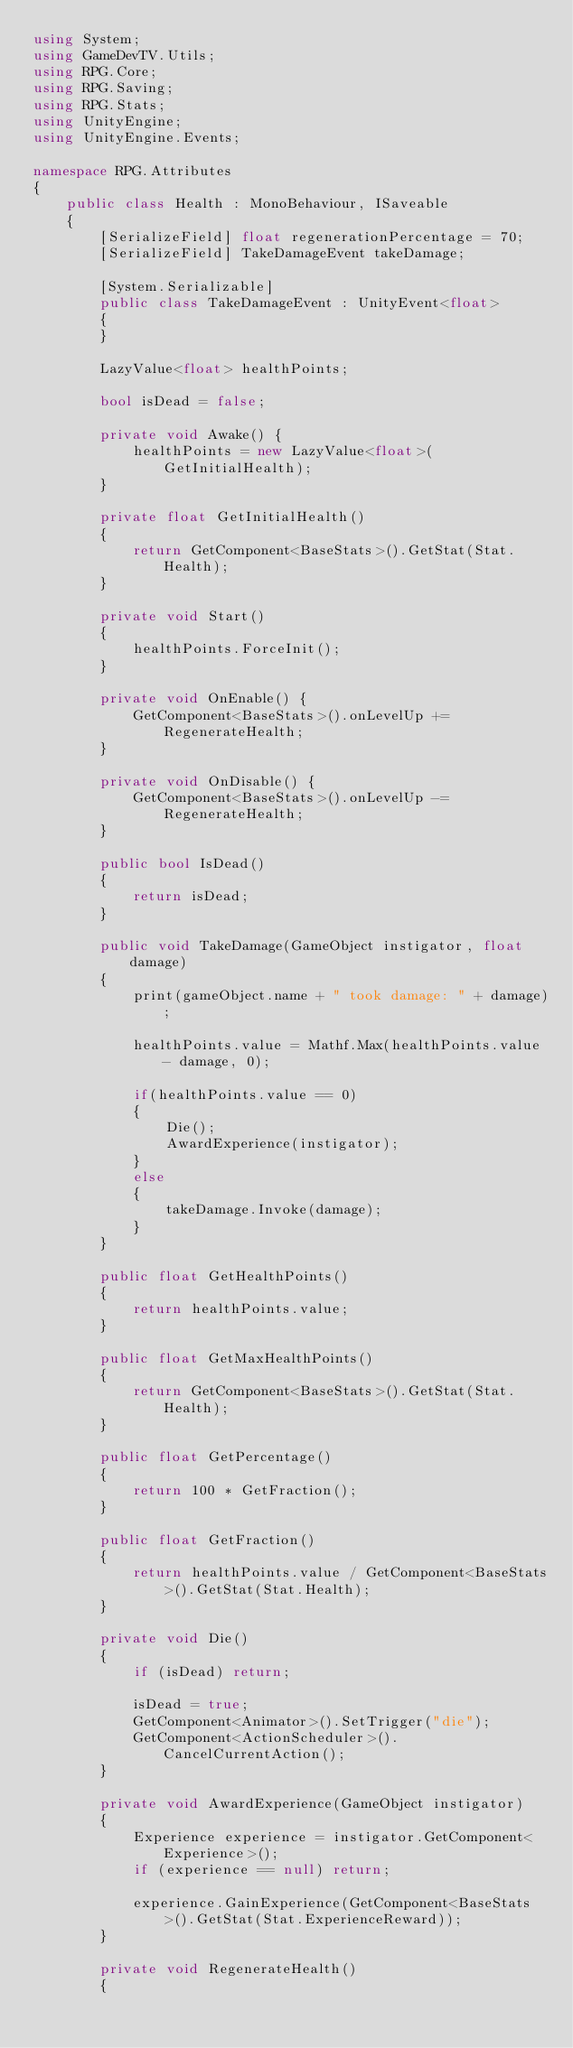Convert code to text. <code><loc_0><loc_0><loc_500><loc_500><_C#_>using System;
using GameDevTV.Utils;
using RPG.Core;
using RPG.Saving;
using RPG.Stats;
using UnityEngine;
using UnityEngine.Events;

namespace RPG.Attributes
{
    public class Health : MonoBehaviour, ISaveable
    {
        [SerializeField] float regenerationPercentage = 70;
        [SerializeField] TakeDamageEvent takeDamage;

        [System.Serializable]
        public class TakeDamageEvent : UnityEvent<float>
        {
        }

        LazyValue<float> healthPoints;

        bool isDead = false;

        private void Awake() {
            healthPoints = new LazyValue<float>(GetInitialHealth);
        }

        private float GetInitialHealth()
        {
            return GetComponent<BaseStats>().GetStat(Stat.Health);
        }

        private void Start()
        {
            healthPoints.ForceInit();
        }

        private void OnEnable() {
            GetComponent<BaseStats>().onLevelUp += RegenerateHealth;
        }

        private void OnDisable() {
            GetComponent<BaseStats>().onLevelUp -= RegenerateHealth;
        }

        public bool IsDead()
        {
            return isDead;
        }

        public void TakeDamage(GameObject instigator, float damage)
        {
            print(gameObject.name + " took damage: " + damage);

            healthPoints.value = Mathf.Max(healthPoints.value - damage, 0);
            
            if(healthPoints.value == 0)
            {
                Die();
                AwardExperience(instigator);
            } 
            else
            {
                takeDamage.Invoke(damage);
            }
        }

        public float GetHealthPoints()
        {
            return healthPoints.value;
        }

        public float GetMaxHealthPoints()
        {
            return GetComponent<BaseStats>().GetStat(Stat.Health);
        }

        public float GetPercentage()
        {
            return 100 * GetFraction();
        }

        public float GetFraction()
        {
            return healthPoints.value / GetComponent<BaseStats>().GetStat(Stat.Health);
        }

        private void Die()
        {
            if (isDead) return;

            isDead = true;
            GetComponent<Animator>().SetTrigger("die");
            GetComponent<ActionScheduler>().CancelCurrentAction();
        }

        private void AwardExperience(GameObject instigator)
        {
            Experience experience = instigator.GetComponent<Experience>();
            if (experience == null) return;

            experience.GainExperience(GetComponent<BaseStats>().GetStat(Stat.ExperienceReward));
        }

        private void RegenerateHealth()
        {</code> 